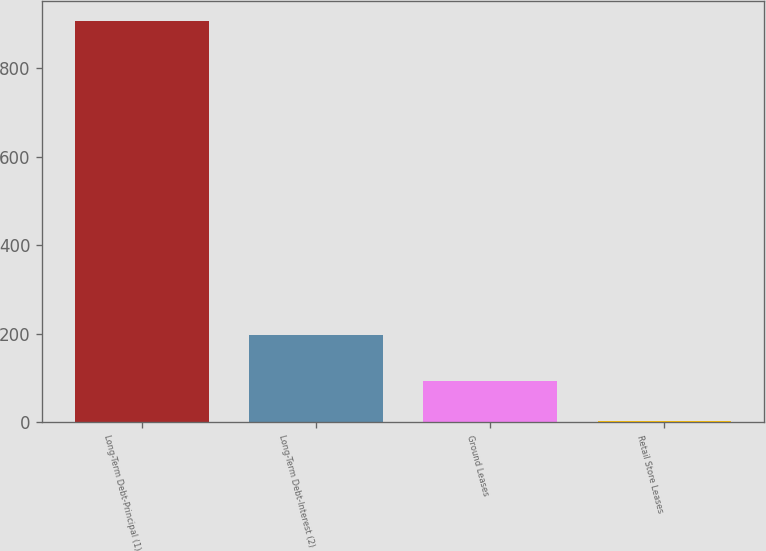<chart> <loc_0><loc_0><loc_500><loc_500><bar_chart><fcel>Long-Term Debt-Principal (1)<fcel>Long-Term Debt-Interest (2)<fcel>Ground Leases<fcel>Retail Store Leases<nl><fcel>907.2<fcel>196.9<fcel>92.61<fcel>2.1<nl></chart> 